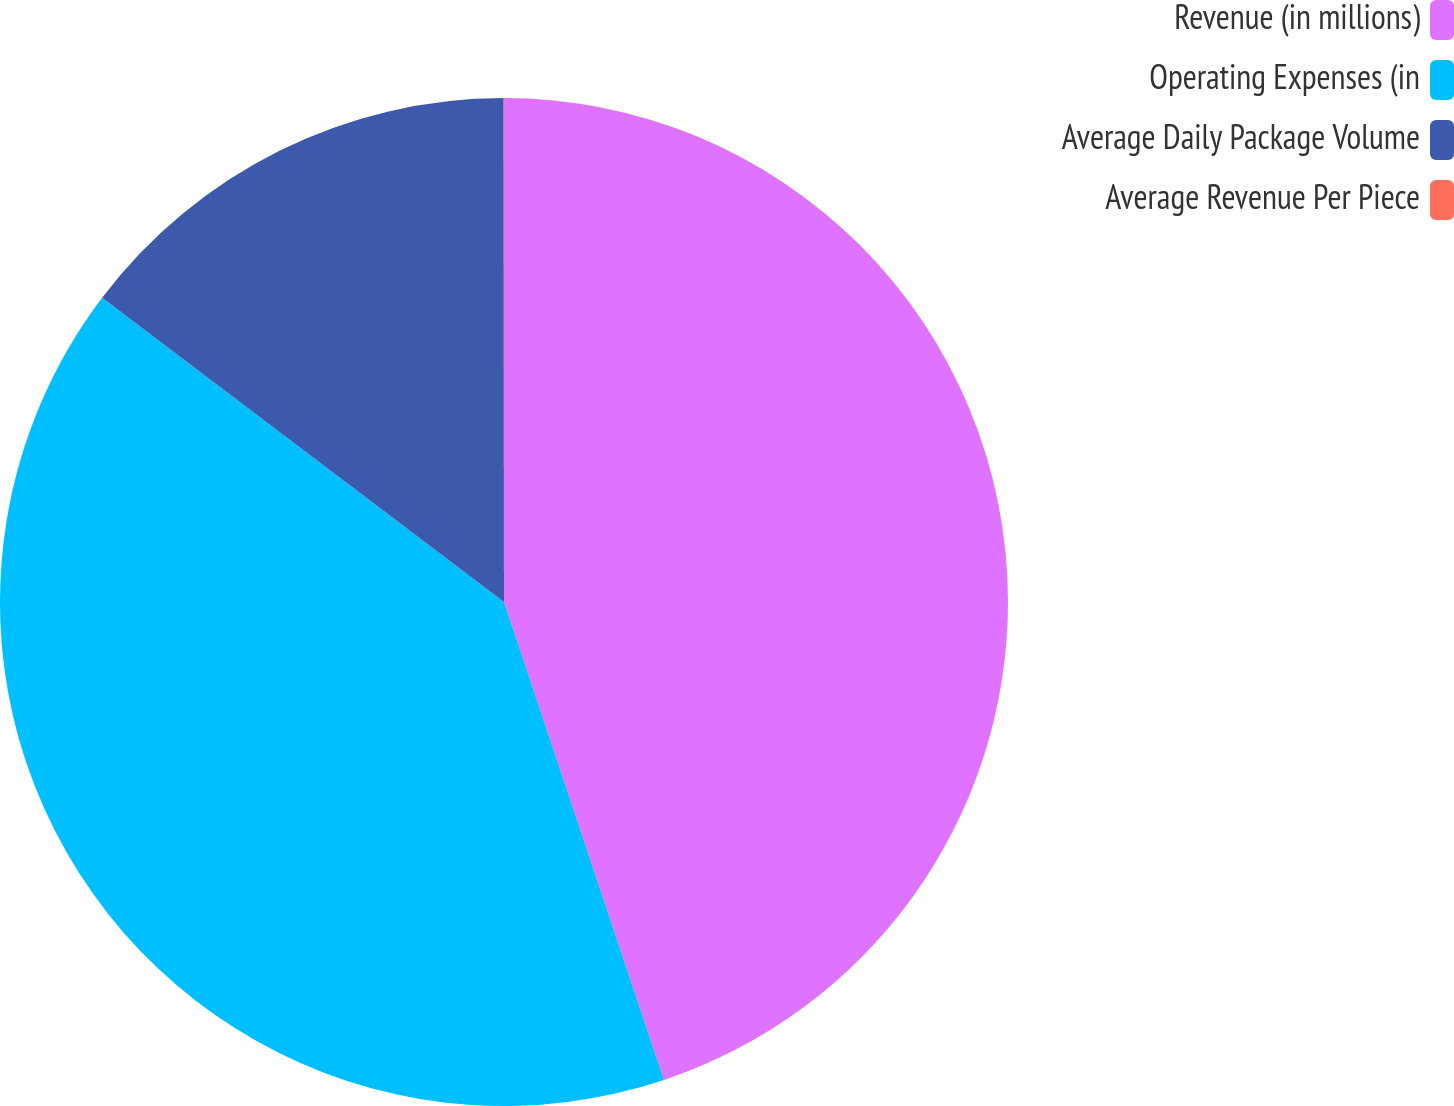<chart> <loc_0><loc_0><loc_500><loc_500><pie_chart><fcel>Revenue (in millions)<fcel>Operating Expenses (in<fcel>Average Daily Package Volume<fcel>Average Revenue Per Piece<nl><fcel>44.86%<fcel>40.45%<fcel>14.68%<fcel>0.01%<nl></chart> 